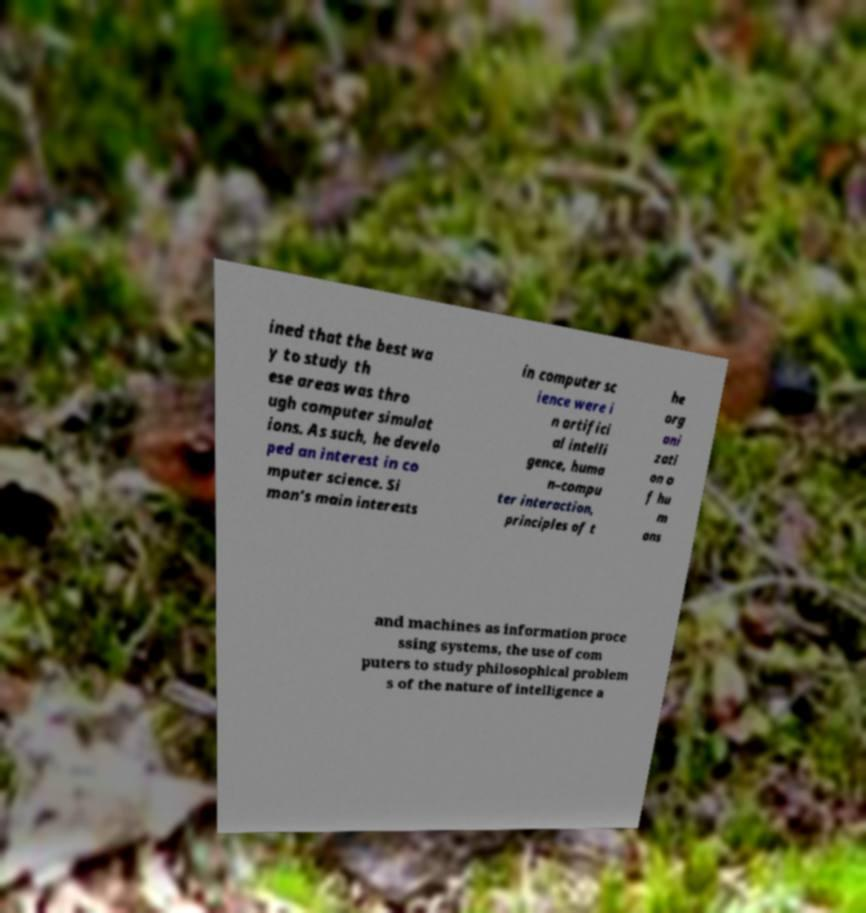Please identify and transcribe the text found in this image. ined that the best wa y to study th ese areas was thro ugh computer simulat ions. As such, he develo ped an interest in co mputer science. Si mon's main interests in computer sc ience were i n artifici al intelli gence, huma n–compu ter interaction, principles of t he org ani zati on o f hu m ans and machines as information proce ssing systems, the use of com puters to study philosophical problem s of the nature of intelligence a 